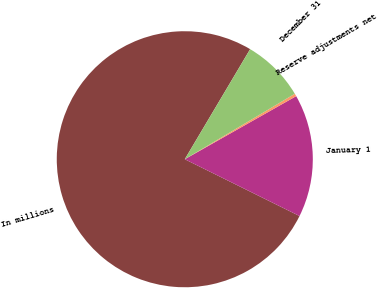Convert chart. <chart><loc_0><loc_0><loc_500><loc_500><pie_chart><fcel>In millions<fcel>January 1<fcel>Reserve adjustments net<fcel>December 31<nl><fcel>76.22%<fcel>15.52%<fcel>0.34%<fcel>7.93%<nl></chart> 